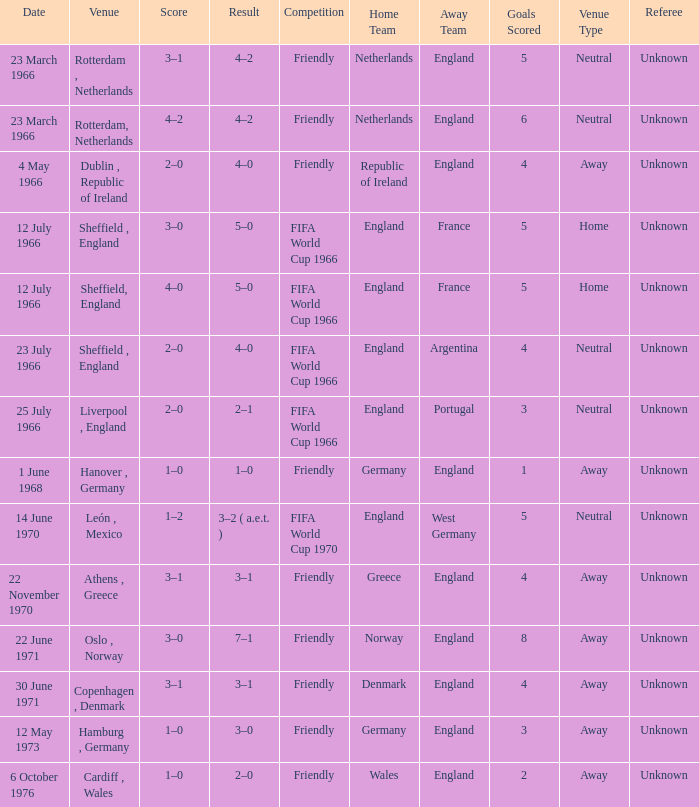Which result's venue was in Rotterdam, Netherlands? 4–2, 4–2. 